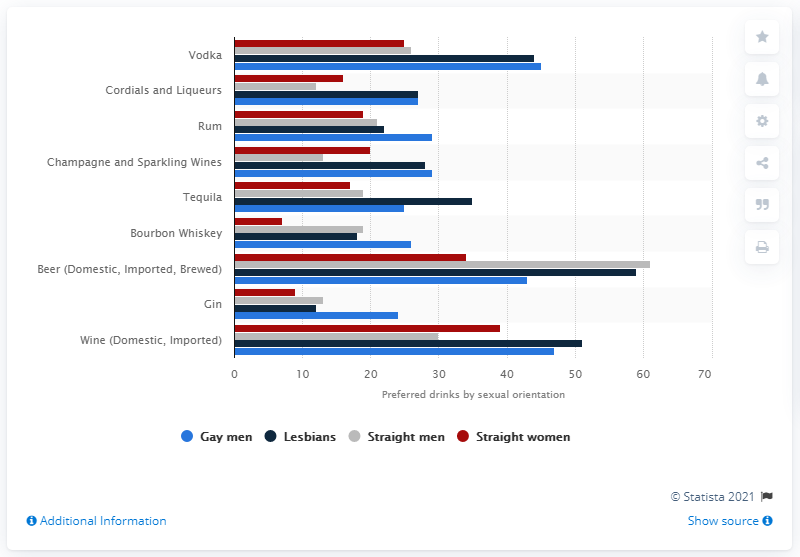What does the bar chart reveal about the preference for rum among different demographics? The bar chart shows that approximately 30% of gay men, 25% of lesbians, and around 27% of straight men and women prefer rum, indicating a relatively moderate preference across all groups compared to other drinks like vodka. 